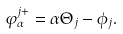<formula> <loc_0><loc_0><loc_500><loc_500>\varphi _ { \alpha } ^ { j + } = \alpha \Theta _ { j } - \phi _ { j } .</formula> 